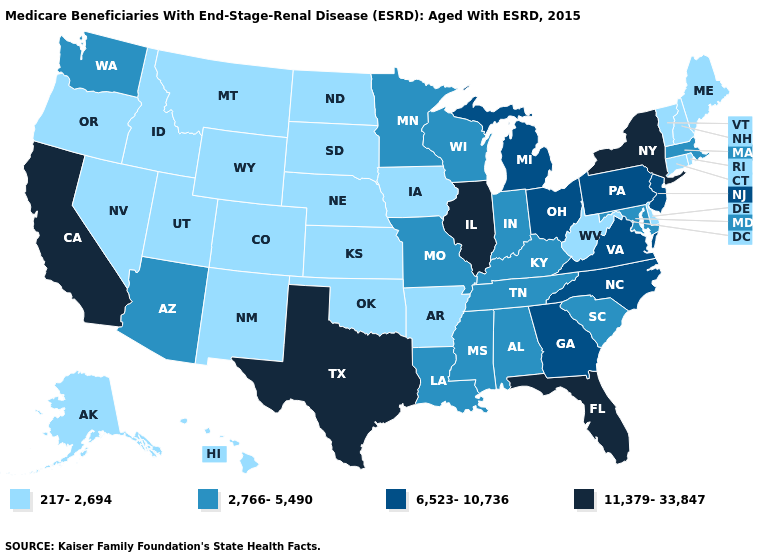Does the map have missing data?
Concise answer only. No. Name the states that have a value in the range 2,766-5,490?
Short answer required. Alabama, Arizona, Indiana, Kentucky, Louisiana, Maryland, Massachusetts, Minnesota, Mississippi, Missouri, South Carolina, Tennessee, Washington, Wisconsin. How many symbols are there in the legend?
Be succinct. 4. What is the value of Pennsylvania?
Write a very short answer. 6,523-10,736. What is the highest value in states that border Washington?
Be succinct. 217-2,694. What is the value of Nevada?
Quick response, please. 217-2,694. Name the states that have a value in the range 217-2,694?
Quick response, please. Alaska, Arkansas, Colorado, Connecticut, Delaware, Hawaii, Idaho, Iowa, Kansas, Maine, Montana, Nebraska, Nevada, New Hampshire, New Mexico, North Dakota, Oklahoma, Oregon, Rhode Island, South Dakota, Utah, Vermont, West Virginia, Wyoming. What is the value of Alaska?
Keep it brief. 217-2,694. Among the states that border North Dakota , does Montana have the highest value?
Answer briefly. No. What is the highest value in the MidWest ?
Short answer required. 11,379-33,847. Which states hav the highest value in the West?
Quick response, please. California. What is the value of New Jersey?
Answer briefly. 6,523-10,736. Name the states that have a value in the range 2,766-5,490?
Quick response, please. Alabama, Arizona, Indiana, Kentucky, Louisiana, Maryland, Massachusetts, Minnesota, Mississippi, Missouri, South Carolina, Tennessee, Washington, Wisconsin. Name the states that have a value in the range 6,523-10,736?
Concise answer only. Georgia, Michigan, New Jersey, North Carolina, Ohio, Pennsylvania, Virginia. What is the value of New Mexico?
Concise answer only. 217-2,694. 